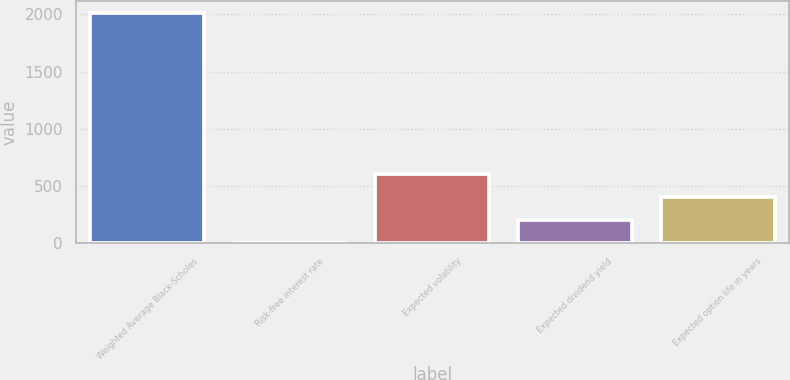Convert chart. <chart><loc_0><loc_0><loc_500><loc_500><bar_chart><fcel>Weighted Average Black-Scholes<fcel>Risk-free interest rate<fcel>Expected volatility<fcel>Expected dividend yield<fcel>Expected option life in years<nl><fcel>2016<fcel>1.2<fcel>605.64<fcel>202.68<fcel>404.16<nl></chart> 